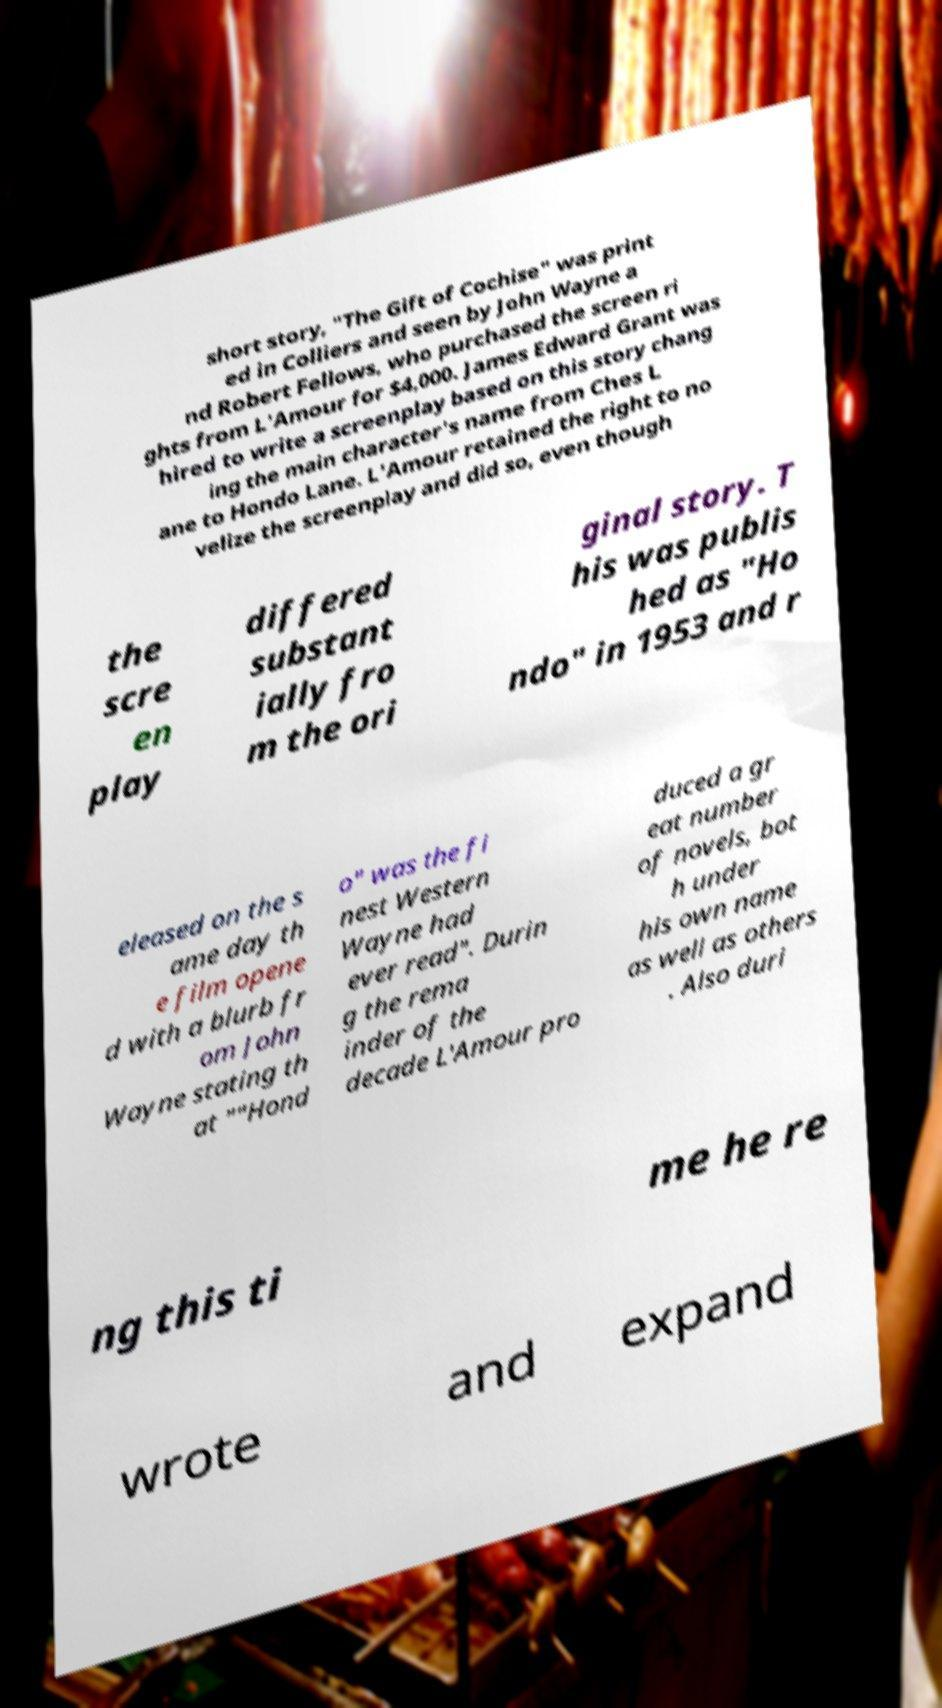What messages or text are displayed in this image? I need them in a readable, typed format. short story, "The Gift of Cochise" was print ed in Colliers and seen by John Wayne a nd Robert Fellows, who purchased the screen ri ghts from L'Amour for $4,000. James Edward Grant was hired to write a screenplay based on this story chang ing the main character's name from Ches L ane to Hondo Lane. L'Amour retained the right to no velize the screenplay and did so, even though the scre en play differed substant ially fro m the ori ginal story. T his was publis hed as "Ho ndo" in 1953 and r eleased on the s ame day th e film opene d with a blurb fr om John Wayne stating th at ""Hond o" was the fi nest Western Wayne had ever read". Durin g the rema inder of the decade L'Amour pro duced a gr eat number of novels, bot h under his own name as well as others . Also duri ng this ti me he re wrote and expand 